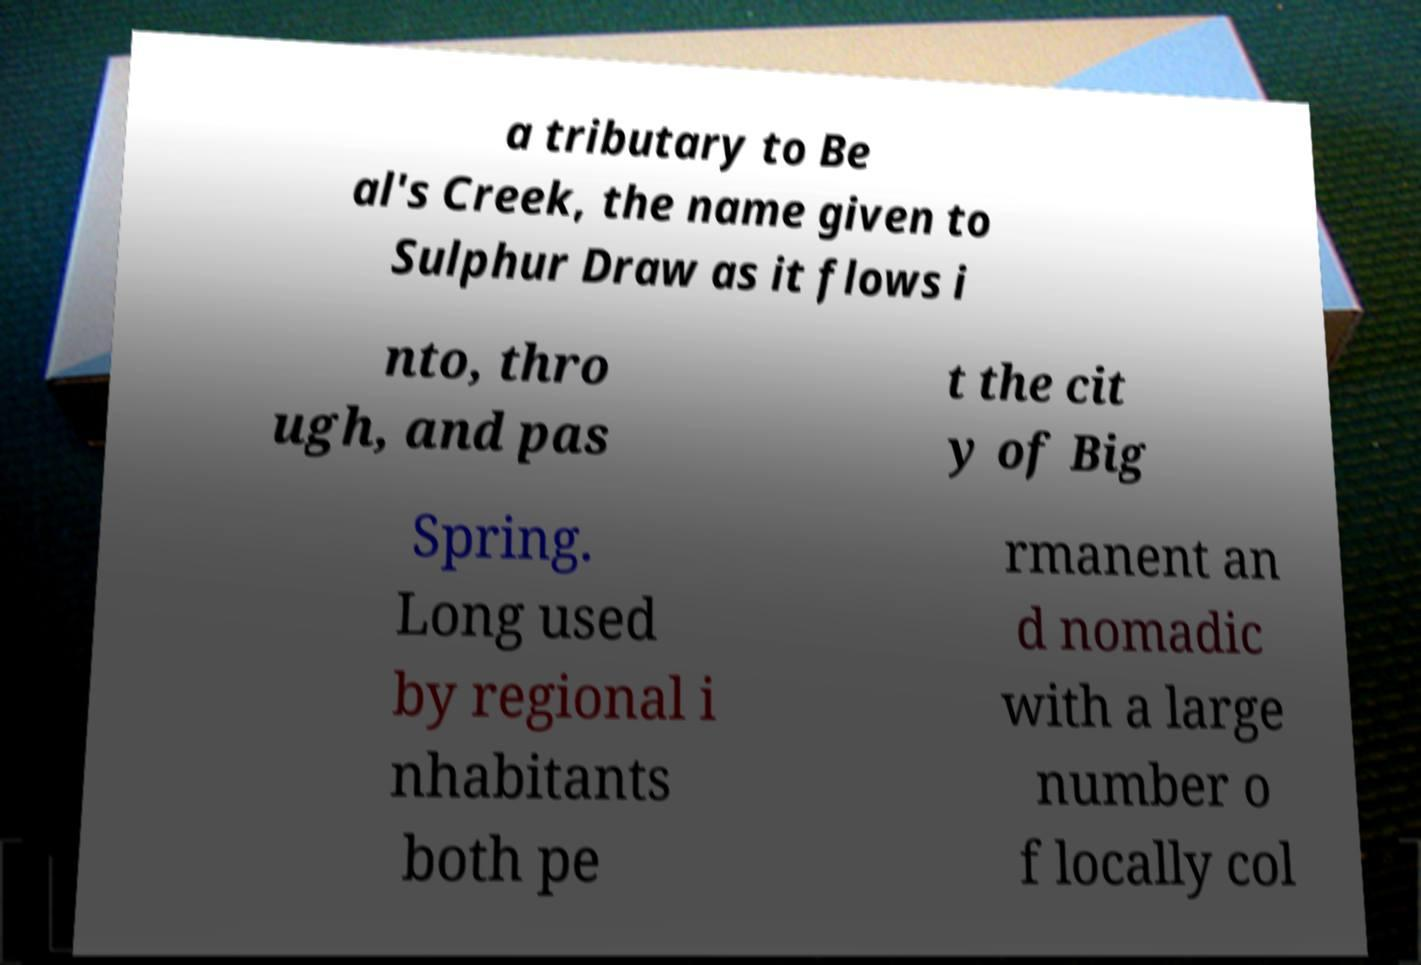Could you extract and type out the text from this image? a tributary to Be al's Creek, the name given to Sulphur Draw as it flows i nto, thro ugh, and pas t the cit y of Big Spring. Long used by regional i nhabitants both pe rmanent an d nomadic with a large number o f locally col 